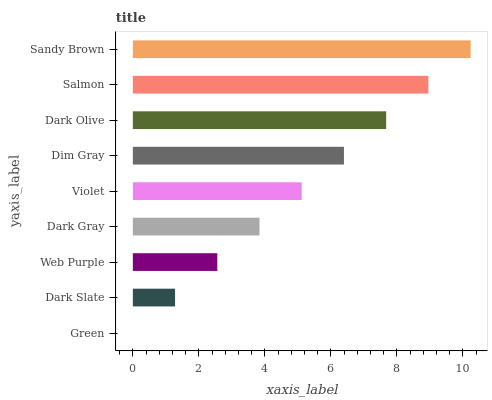Is Green the minimum?
Answer yes or no. Yes. Is Sandy Brown the maximum?
Answer yes or no. Yes. Is Dark Slate the minimum?
Answer yes or no. No. Is Dark Slate the maximum?
Answer yes or no. No. Is Dark Slate greater than Green?
Answer yes or no. Yes. Is Green less than Dark Slate?
Answer yes or no. Yes. Is Green greater than Dark Slate?
Answer yes or no. No. Is Dark Slate less than Green?
Answer yes or no. No. Is Violet the high median?
Answer yes or no. Yes. Is Violet the low median?
Answer yes or no. Yes. Is Dim Gray the high median?
Answer yes or no. No. Is Green the low median?
Answer yes or no. No. 